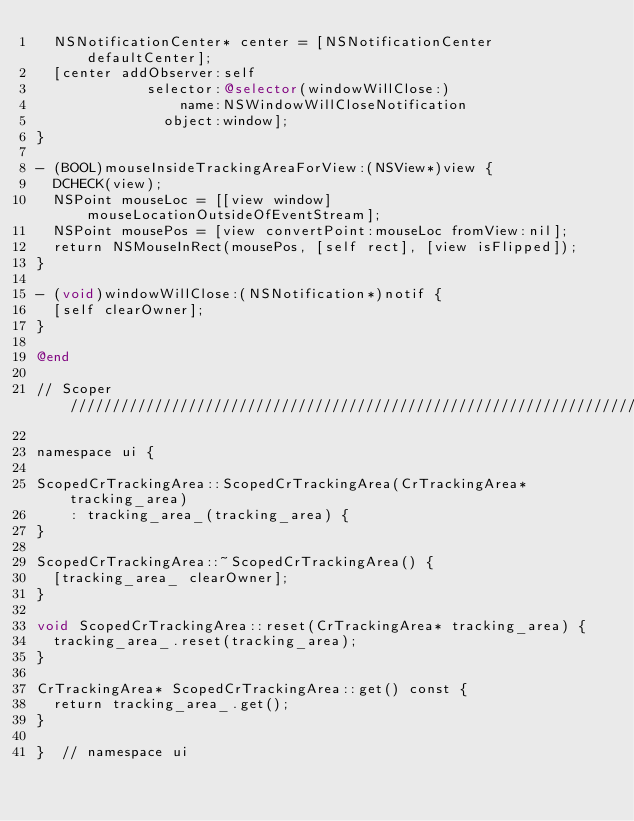<code> <loc_0><loc_0><loc_500><loc_500><_ObjectiveC_>  NSNotificationCenter* center = [NSNotificationCenter defaultCenter];
  [center addObserver:self
             selector:@selector(windowWillClose:)
                 name:NSWindowWillCloseNotification
               object:window];
}

- (BOOL)mouseInsideTrackingAreaForView:(NSView*)view {
  DCHECK(view);
  NSPoint mouseLoc = [[view window] mouseLocationOutsideOfEventStream];
  NSPoint mousePos = [view convertPoint:mouseLoc fromView:nil];
  return NSMouseInRect(mousePos, [self rect], [view isFlipped]);
}

- (void)windowWillClose:(NSNotification*)notif {
  [self clearOwner];
}

@end

// Scoper //////////////////////////////////////////////////////////////////////

namespace ui {

ScopedCrTrackingArea::ScopedCrTrackingArea(CrTrackingArea* tracking_area)
    : tracking_area_(tracking_area) {
}

ScopedCrTrackingArea::~ScopedCrTrackingArea() {
  [tracking_area_ clearOwner];
}

void ScopedCrTrackingArea::reset(CrTrackingArea* tracking_area) {
  tracking_area_.reset(tracking_area);
}

CrTrackingArea* ScopedCrTrackingArea::get() const {
  return tracking_area_.get();
}

}  // namespace ui
</code> 